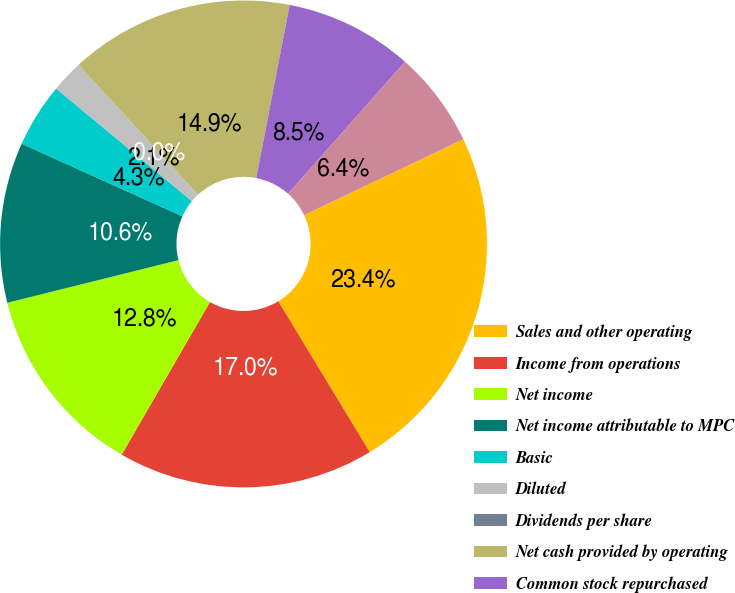Convert chart. <chart><loc_0><loc_0><loc_500><loc_500><pie_chart><fcel>Sales and other operating<fcel>Income from operations<fcel>Net income<fcel>Net income attributable to MPC<fcel>Basic<fcel>Diluted<fcel>Dividends per share<fcel>Net cash provided by operating<fcel>Common stock repurchased<fcel>Dividends paid<nl><fcel>23.4%<fcel>17.02%<fcel>12.77%<fcel>10.64%<fcel>4.26%<fcel>2.13%<fcel>0.0%<fcel>14.89%<fcel>8.51%<fcel>6.38%<nl></chart> 